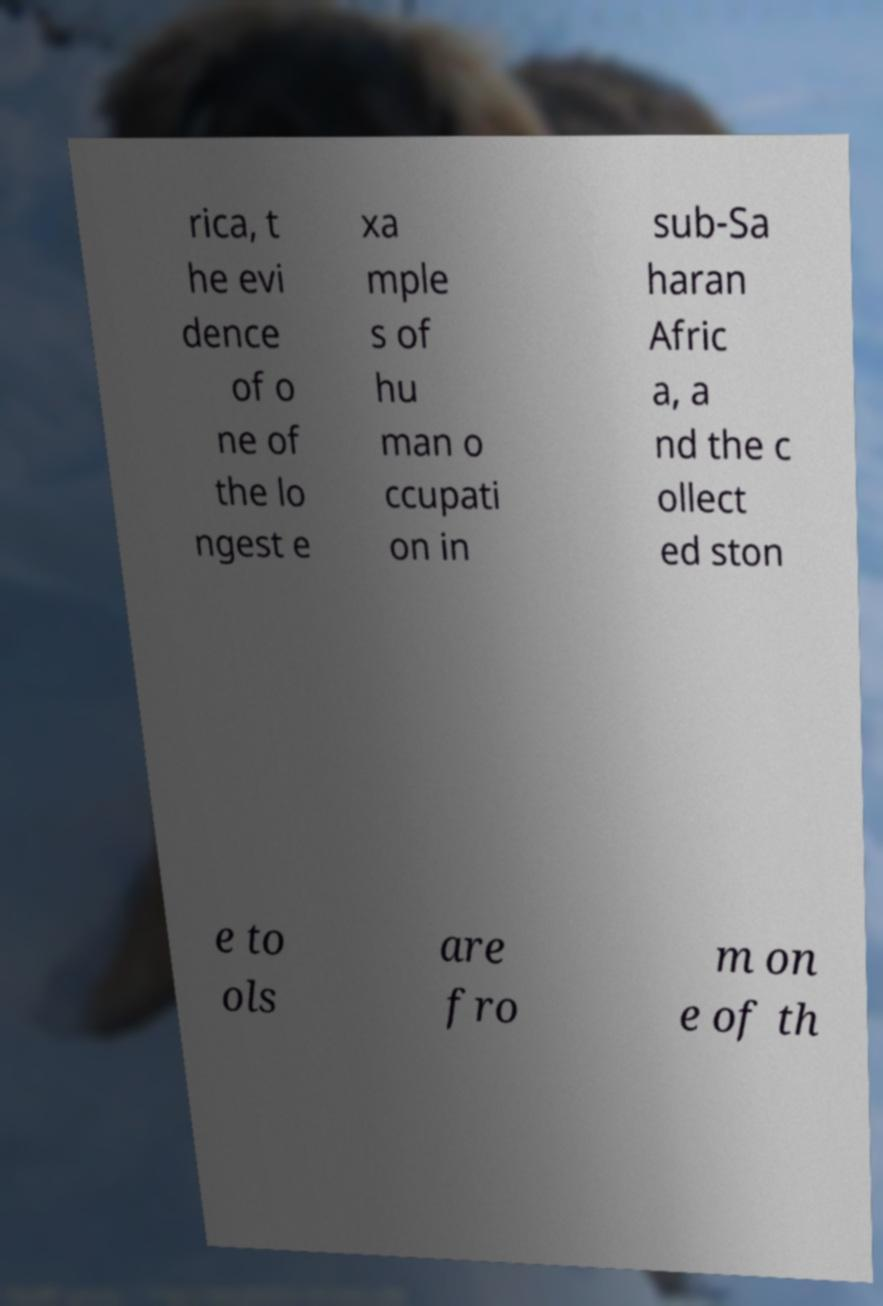There's text embedded in this image that I need extracted. Can you transcribe it verbatim? rica, t he evi dence of o ne of the lo ngest e xa mple s of hu man o ccupati on in sub-Sa haran Afric a, a nd the c ollect ed ston e to ols are fro m on e of th 